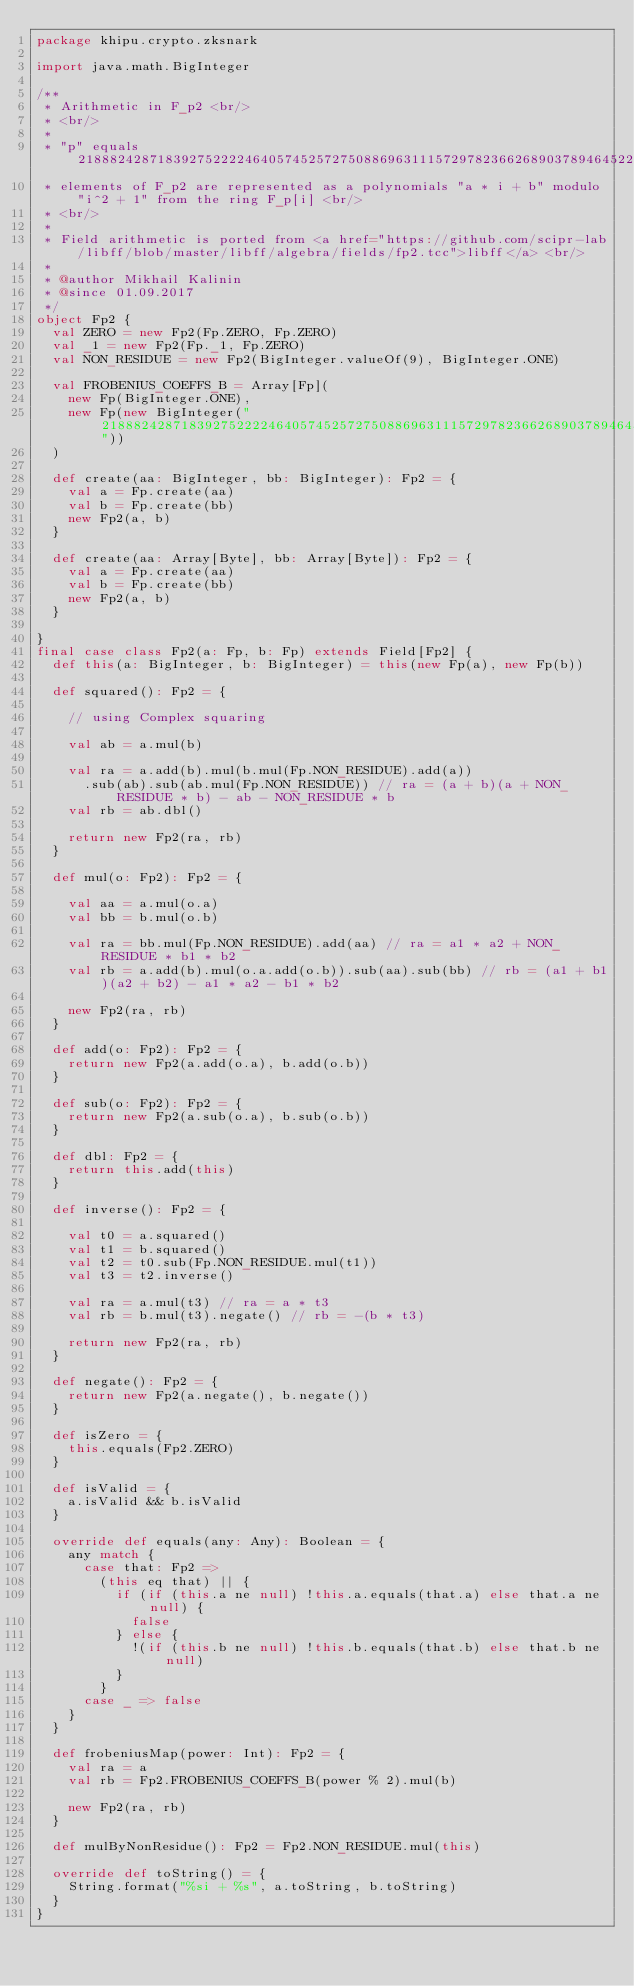<code> <loc_0><loc_0><loc_500><loc_500><_Scala_>package khipu.crypto.zksnark

import java.math.BigInteger

/**
 * Arithmetic in F_p2 <br/>
 * <br/>
 *
 * "p" equals 21888242871839275222246405745257275088696311157297823662689037894645226208583,
 * elements of F_p2 are represented as a polynomials "a * i + b" modulo "i^2 + 1" from the ring F_p[i] <br/>
 * <br/>
 *
 * Field arithmetic is ported from <a href="https://github.com/scipr-lab/libff/blob/master/libff/algebra/fields/fp2.tcc">libff</a> <br/>
 *
 * @author Mikhail Kalinin
 * @since 01.09.2017
 */
object Fp2 {
  val ZERO = new Fp2(Fp.ZERO, Fp.ZERO)
  val _1 = new Fp2(Fp._1, Fp.ZERO)
  val NON_RESIDUE = new Fp2(BigInteger.valueOf(9), BigInteger.ONE)

  val FROBENIUS_COEFFS_B = Array[Fp](
    new Fp(BigInteger.ONE),
    new Fp(new BigInteger("21888242871839275222246405745257275088696311157297823662689037894645226208582"))
  )

  def create(aa: BigInteger, bb: BigInteger): Fp2 = {
    val a = Fp.create(aa)
    val b = Fp.create(bb)
    new Fp2(a, b)
  }

  def create(aa: Array[Byte], bb: Array[Byte]): Fp2 = {
    val a = Fp.create(aa)
    val b = Fp.create(bb)
    new Fp2(a, b)
  }

}
final case class Fp2(a: Fp, b: Fp) extends Field[Fp2] {
  def this(a: BigInteger, b: BigInteger) = this(new Fp(a), new Fp(b))

  def squared(): Fp2 = {

    // using Complex squaring

    val ab = a.mul(b)

    val ra = a.add(b).mul(b.mul(Fp.NON_RESIDUE).add(a))
      .sub(ab).sub(ab.mul(Fp.NON_RESIDUE)) // ra = (a + b)(a + NON_RESIDUE * b) - ab - NON_RESIDUE * b
    val rb = ab.dbl()

    return new Fp2(ra, rb)
  }

  def mul(o: Fp2): Fp2 = {

    val aa = a.mul(o.a)
    val bb = b.mul(o.b)

    val ra = bb.mul(Fp.NON_RESIDUE).add(aa) // ra = a1 * a2 + NON_RESIDUE * b1 * b2
    val rb = a.add(b).mul(o.a.add(o.b)).sub(aa).sub(bb) // rb = (a1 + b1)(a2 + b2) - a1 * a2 - b1 * b2

    new Fp2(ra, rb)
  }

  def add(o: Fp2): Fp2 = {
    return new Fp2(a.add(o.a), b.add(o.b))
  }

  def sub(o: Fp2): Fp2 = {
    return new Fp2(a.sub(o.a), b.sub(o.b))
  }

  def dbl: Fp2 = {
    return this.add(this)
  }

  def inverse(): Fp2 = {

    val t0 = a.squared()
    val t1 = b.squared()
    val t2 = t0.sub(Fp.NON_RESIDUE.mul(t1))
    val t3 = t2.inverse()

    val ra = a.mul(t3) // ra = a * t3
    val rb = b.mul(t3).negate() // rb = -(b * t3)

    return new Fp2(ra, rb)
  }

  def negate(): Fp2 = {
    return new Fp2(a.negate(), b.negate())
  }

  def isZero = {
    this.equals(Fp2.ZERO)
  }

  def isValid = {
    a.isValid && b.isValid
  }

  override def equals(any: Any): Boolean = {
    any match {
      case that: Fp2 =>
        (this eq that) || {
          if (if (this.a ne null) !this.a.equals(that.a) else that.a ne null) {
            false
          } else {
            !(if (this.b ne null) !this.b.equals(that.b) else that.b ne null)
          }
        }
      case _ => false
    }
  }

  def frobeniusMap(power: Int): Fp2 = {
    val ra = a
    val rb = Fp2.FROBENIUS_COEFFS_B(power % 2).mul(b)

    new Fp2(ra, rb)
  }

  def mulByNonResidue(): Fp2 = Fp2.NON_RESIDUE.mul(this)

  override def toString() = {
    String.format("%si + %s", a.toString, b.toString)
  }
}
</code> 